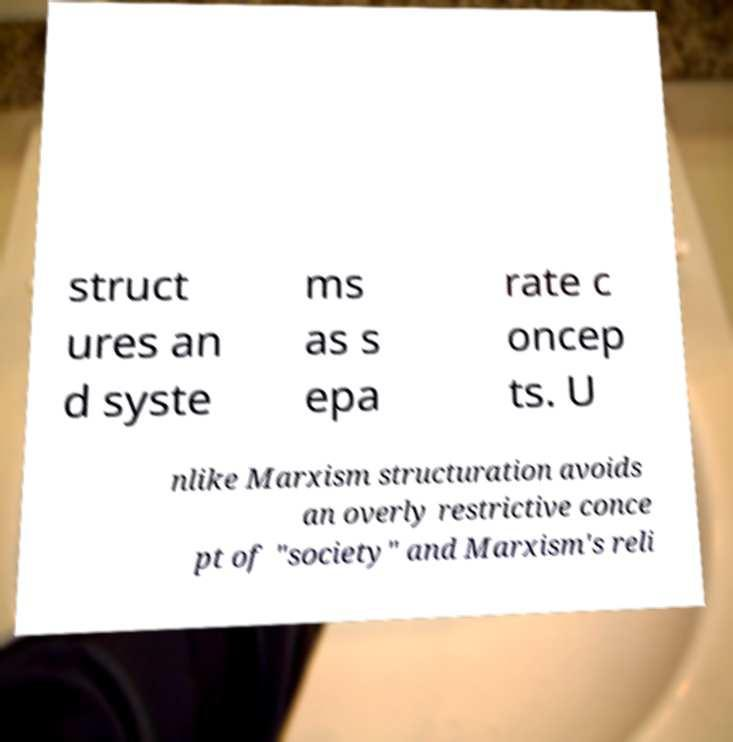There's text embedded in this image that I need extracted. Can you transcribe it verbatim? struct ures an d syste ms as s epa rate c oncep ts. U nlike Marxism structuration avoids an overly restrictive conce pt of "society" and Marxism's reli 